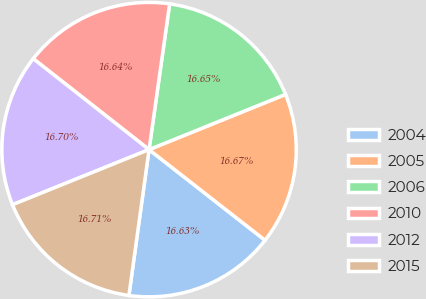<chart> <loc_0><loc_0><loc_500><loc_500><pie_chart><fcel>2004<fcel>2005<fcel>2006<fcel>2010<fcel>2012<fcel>2015<nl><fcel>16.63%<fcel>16.67%<fcel>16.65%<fcel>16.64%<fcel>16.7%<fcel>16.71%<nl></chart> 